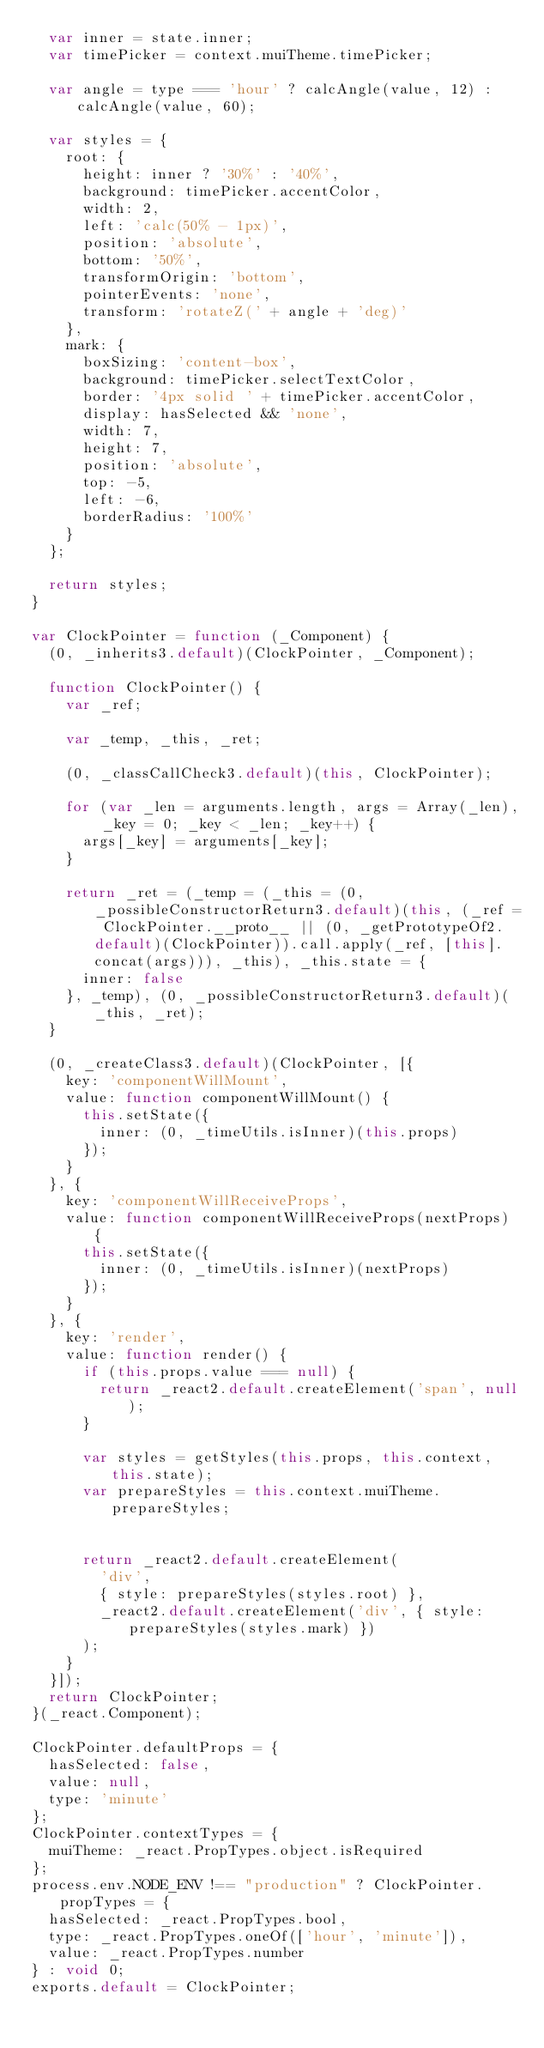<code> <loc_0><loc_0><loc_500><loc_500><_JavaScript_>  var inner = state.inner;
  var timePicker = context.muiTheme.timePicker;

  var angle = type === 'hour' ? calcAngle(value, 12) : calcAngle(value, 60);

  var styles = {
    root: {
      height: inner ? '30%' : '40%',
      background: timePicker.accentColor,
      width: 2,
      left: 'calc(50% - 1px)',
      position: 'absolute',
      bottom: '50%',
      transformOrigin: 'bottom',
      pointerEvents: 'none',
      transform: 'rotateZ(' + angle + 'deg)'
    },
    mark: {
      boxSizing: 'content-box',
      background: timePicker.selectTextColor,
      border: '4px solid ' + timePicker.accentColor,
      display: hasSelected && 'none',
      width: 7,
      height: 7,
      position: 'absolute',
      top: -5,
      left: -6,
      borderRadius: '100%'
    }
  };

  return styles;
}

var ClockPointer = function (_Component) {
  (0, _inherits3.default)(ClockPointer, _Component);

  function ClockPointer() {
    var _ref;

    var _temp, _this, _ret;

    (0, _classCallCheck3.default)(this, ClockPointer);

    for (var _len = arguments.length, args = Array(_len), _key = 0; _key < _len; _key++) {
      args[_key] = arguments[_key];
    }

    return _ret = (_temp = (_this = (0, _possibleConstructorReturn3.default)(this, (_ref = ClockPointer.__proto__ || (0, _getPrototypeOf2.default)(ClockPointer)).call.apply(_ref, [this].concat(args))), _this), _this.state = {
      inner: false
    }, _temp), (0, _possibleConstructorReturn3.default)(_this, _ret);
  }

  (0, _createClass3.default)(ClockPointer, [{
    key: 'componentWillMount',
    value: function componentWillMount() {
      this.setState({
        inner: (0, _timeUtils.isInner)(this.props)
      });
    }
  }, {
    key: 'componentWillReceiveProps',
    value: function componentWillReceiveProps(nextProps) {
      this.setState({
        inner: (0, _timeUtils.isInner)(nextProps)
      });
    }
  }, {
    key: 'render',
    value: function render() {
      if (this.props.value === null) {
        return _react2.default.createElement('span', null);
      }

      var styles = getStyles(this.props, this.context, this.state);
      var prepareStyles = this.context.muiTheme.prepareStyles;


      return _react2.default.createElement(
        'div',
        { style: prepareStyles(styles.root) },
        _react2.default.createElement('div', { style: prepareStyles(styles.mark) })
      );
    }
  }]);
  return ClockPointer;
}(_react.Component);

ClockPointer.defaultProps = {
  hasSelected: false,
  value: null,
  type: 'minute'
};
ClockPointer.contextTypes = {
  muiTheme: _react.PropTypes.object.isRequired
};
process.env.NODE_ENV !== "production" ? ClockPointer.propTypes = {
  hasSelected: _react.PropTypes.bool,
  type: _react.PropTypes.oneOf(['hour', 'minute']),
  value: _react.PropTypes.number
} : void 0;
exports.default = ClockPointer;</code> 